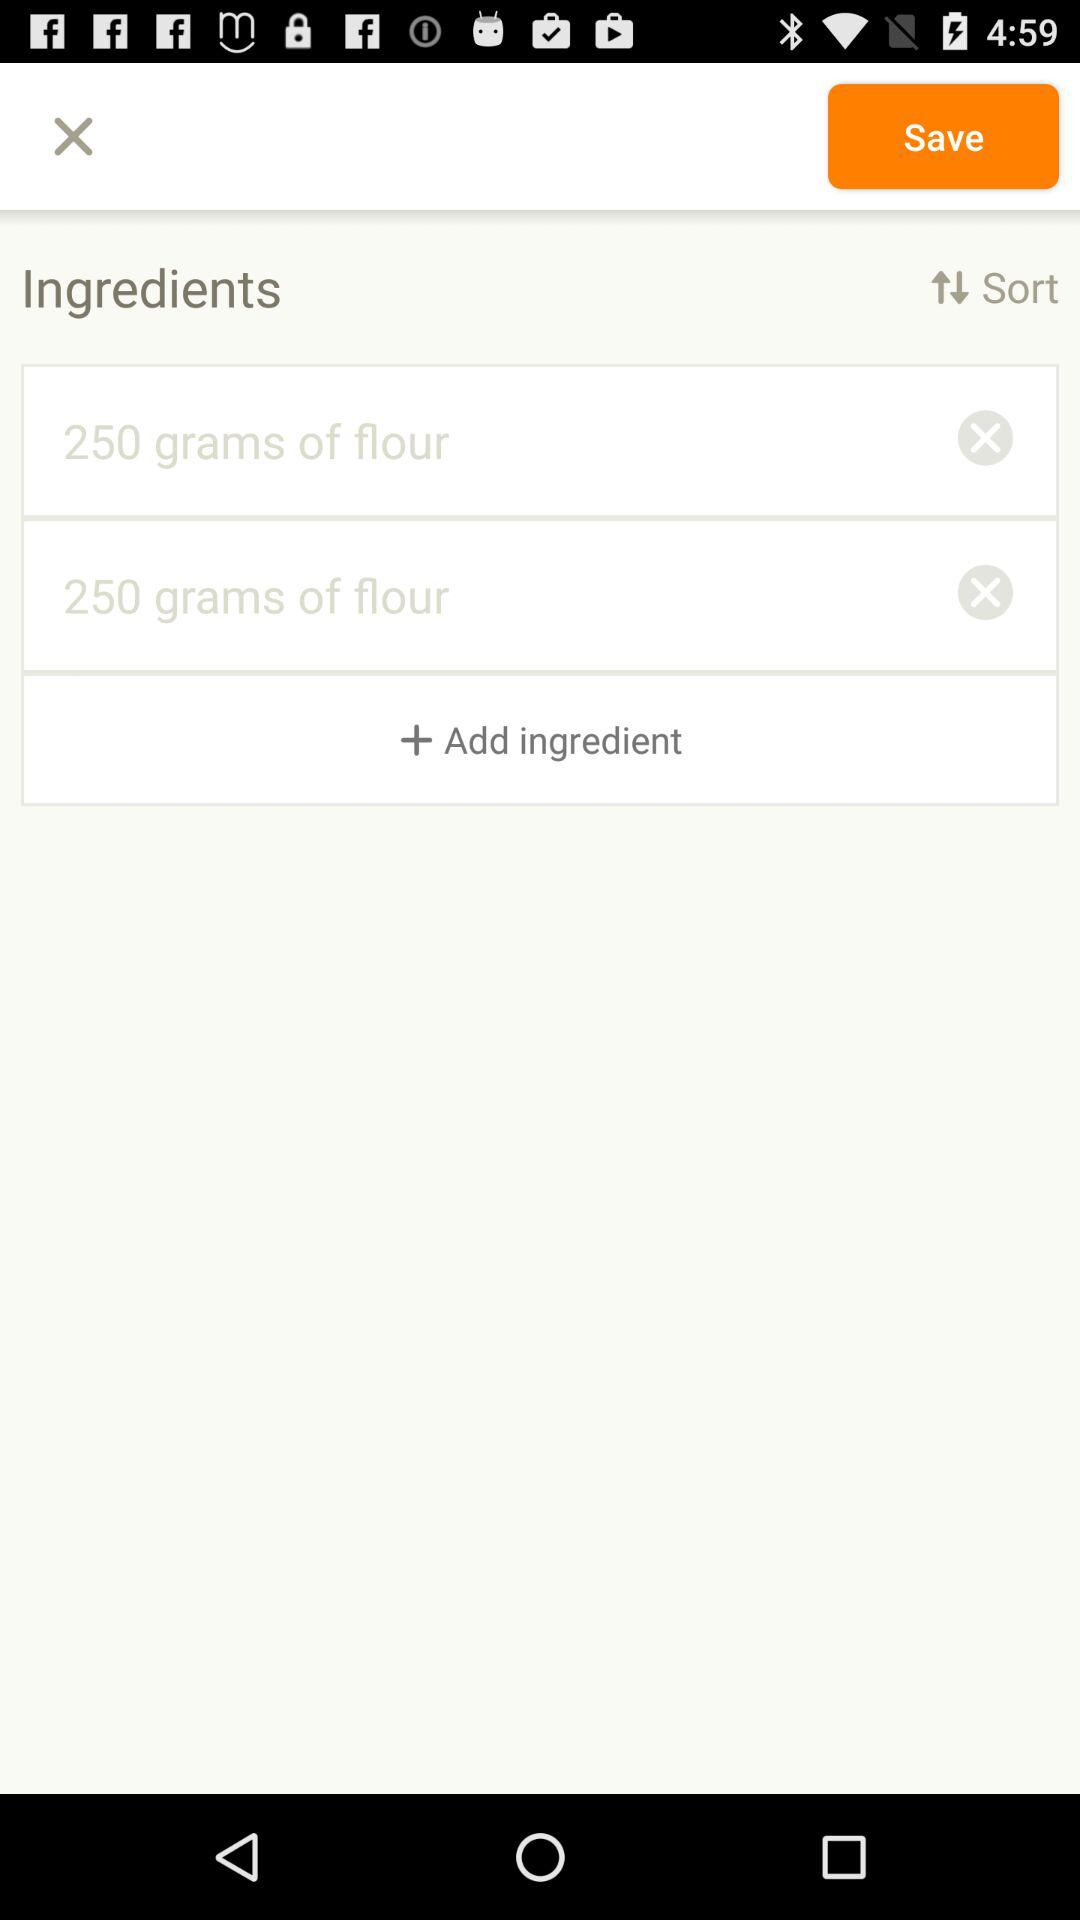What ingredients are added to the list? The added ingredient is flour. 